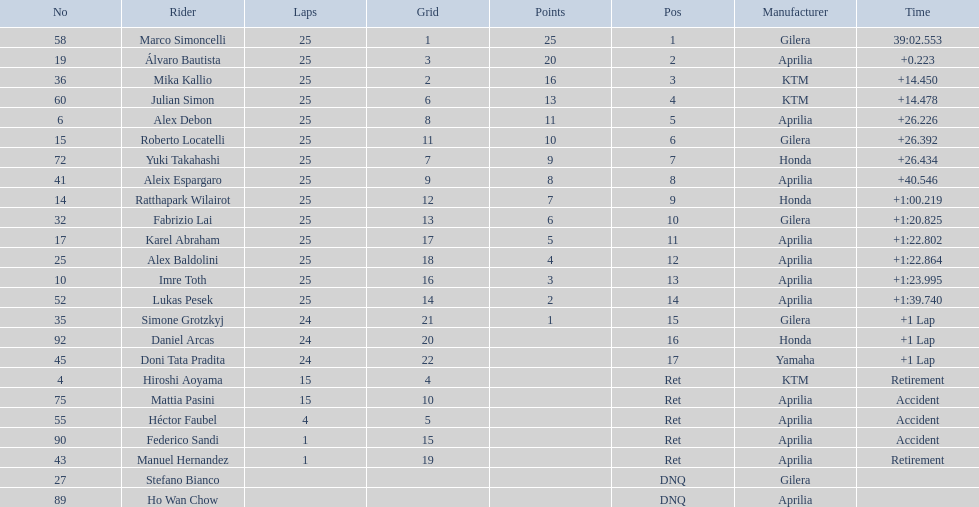How many laps did hiroshi aoyama perform? 15. How many laps did marco simoncelli perform? 25. Who performed more laps out of hiroshi aoyama and marco 
simoncelli? Marco Simoncelli. 